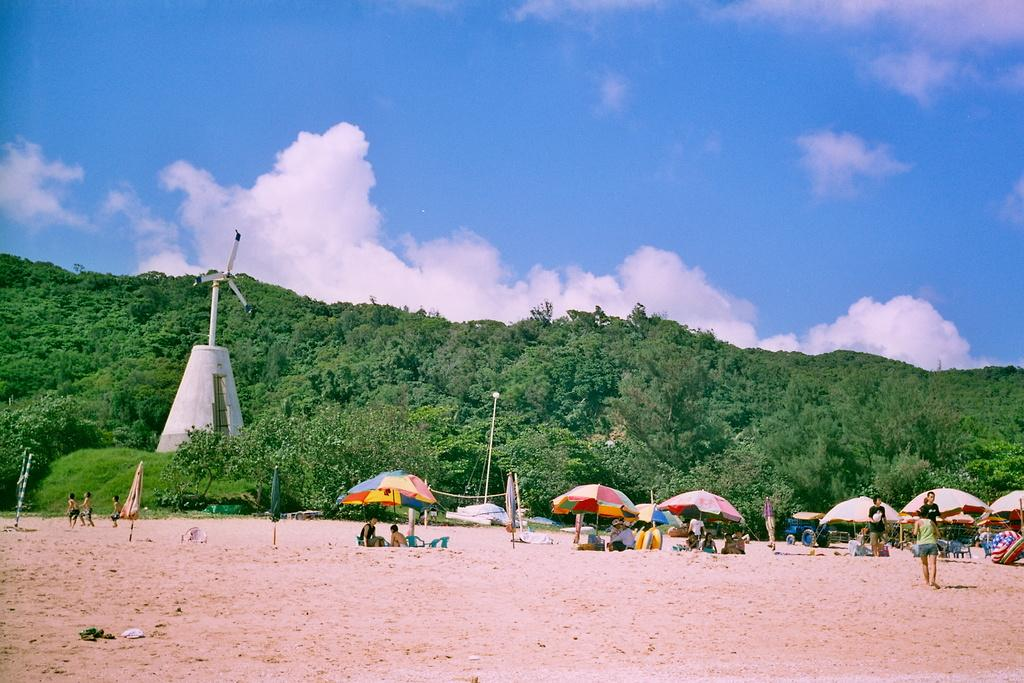How many people are in the image? There is a group of people in the image. What objects are present to provide shade or protection from the elements? There are umbrellas in the image. What type of seating is available in the image? There are chairs in the image. What mode of transportation is visible in the image? There is a vehicle in the image. What type of structure can be seen in the image? There is a windmill in the image. What type of vegetation is present in the image? There are trees in the image. What can be seen in the background of the image? The sky is visible in the background of the image. What is the income of the band performing in the image? There is no band present in the image, so it is not possible to determine their income. Where is the nest of the bird in the image? There is no bird or nest present in the image. 